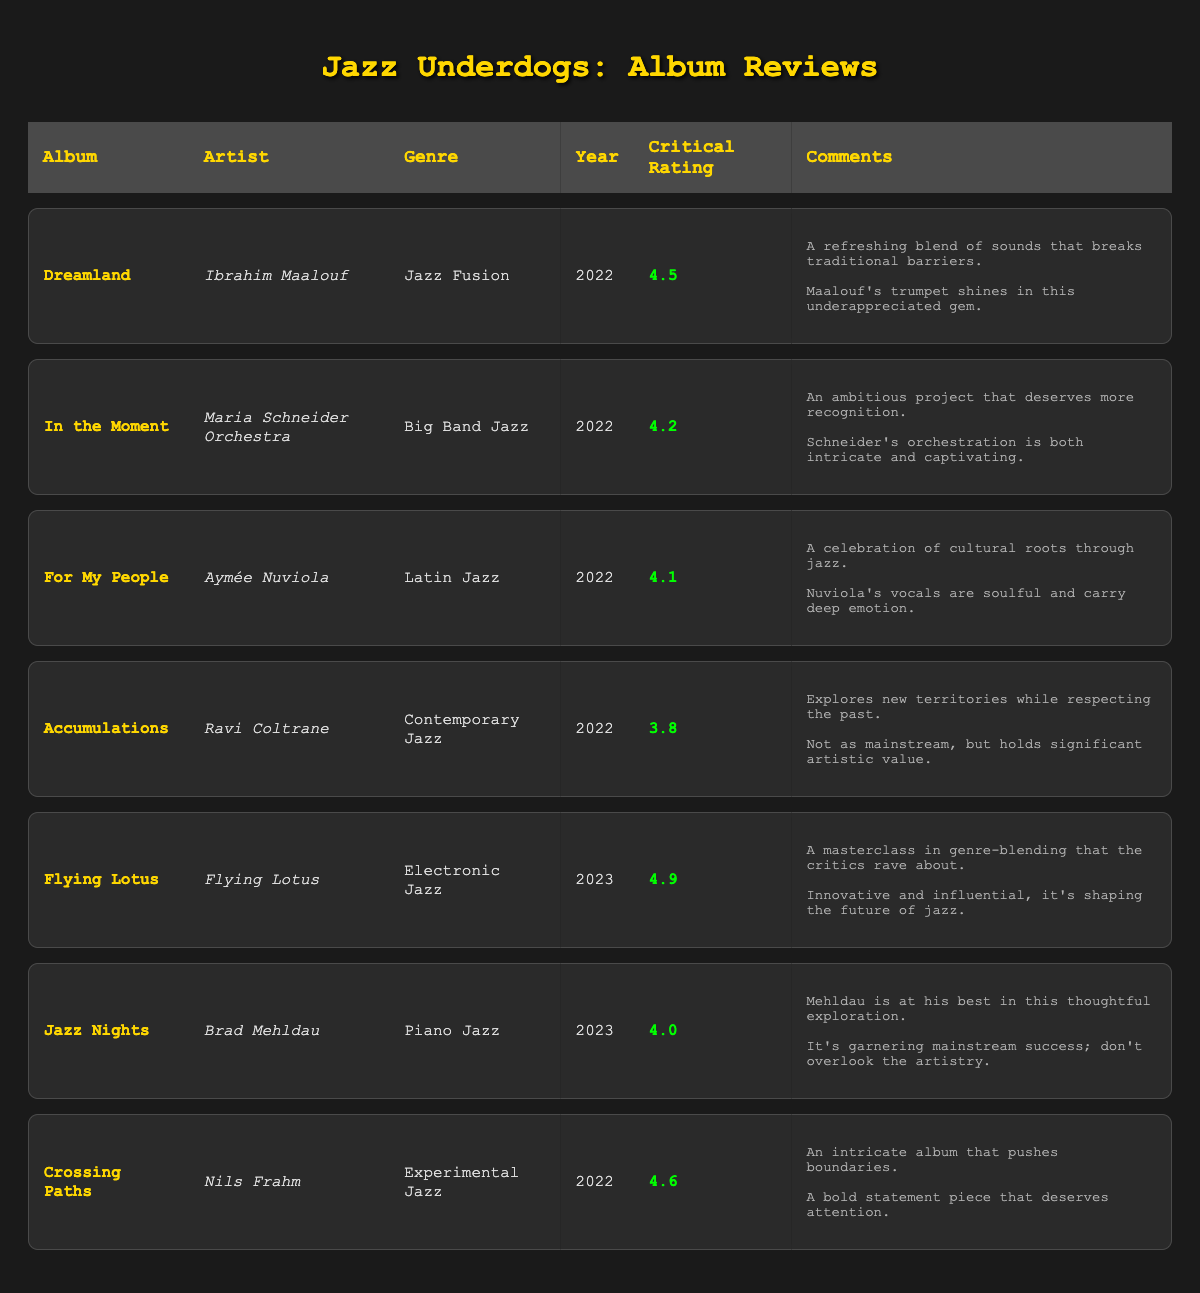What is the highest critical rating among underdog albums? The highest critical rating can be found by checking the "Critical Rating" column for underdog albums. The highest rating listed among "Dreamland," "In the Moment," "For My People," "Accumulations," and "Crossing Paths" is 4.6 for "Crossing Paths."
Answer: 4.6 Which artist released albums in 2022 with an average review score of 4.0 or higher? By reviewing the "Average Review Score" column for 2022 albums, the albums "Dreamland," "In the Moment," "For My People," and "Crossing Paths" have scores of 4.3, 4.0, 3.9, and 4.4 respectively. Thus, the artists are Ibrahim Maalouf, Maria Schneider, and Nils Frahm.
Answer: Ibrahim Maalouf, Maria Schneider, Nils Frahm What is the total number of reviews for the albums listed? To find the total number of reviews, add the "Review Count" for each album: 15 + 20 + 10 + 12 + 40 + 30 + 18 = 145.
Answer: 145 Is "Flying Lotus" the artist with the highest critical rating? "Flying Lotus" has a critical rating of 4.9, which is higher than any other artist in the table. Therefore, yes, they are the artist with the highest critical rating.
Answer: Yes Which album has the most comments, and what is the number of comments? Counting the number of comments for each underdog album: "Dreamland" has 2 comments, "In the Moment" has 2, "For My People" has 2, "Accumulations" has 2, and "Crossing Paths" also has 2, while the others have none. Thus, every underdog album has the same number of comments, which is 2.
Answer: 2 